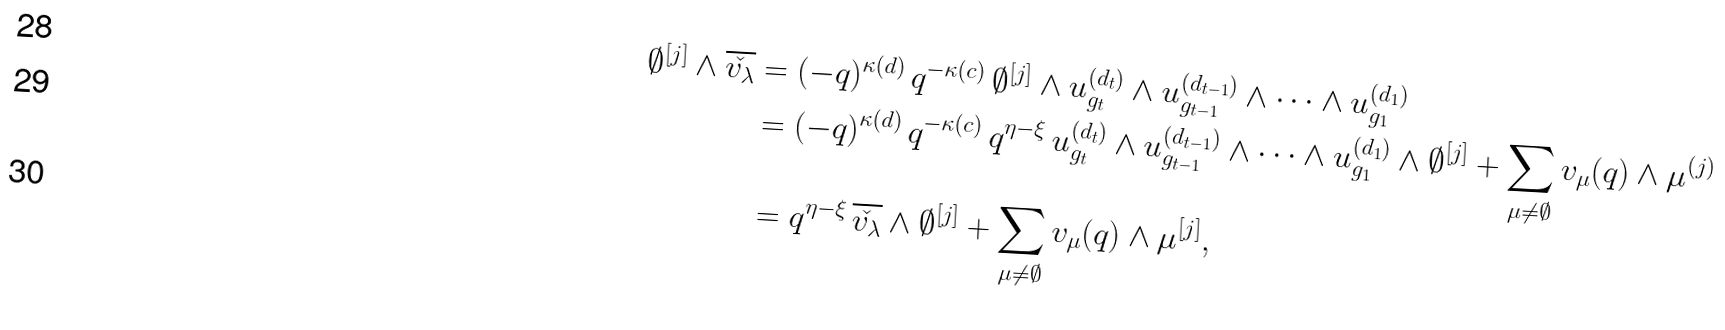Convert formula to latex. <formula><loc_0><loc_0><loc_500><loc_500>\emptyset ^ { [ j ] } \wedge \overline { \check { v _ { \lambda } } } & = ( - q ) ^ { \kappa ( d ) } \, q ^ { - \kappa ( c ) } \, \emptyset ^ { [ j ] } \wedge u _ { g _ { t } } ^ { ( d _ { t } ) } \wedge u _ { g _ { t - 1 } } ^ { ( d _ { t - 1 } ) } \wedge \cdots \wedge u _ { g _ { 1 } } ^ { ( d _ { 1 } ) } \\ & = ( - q ) ^ { \kappa ( d ) } \, q ^ { - \kappa ( c ) } \, q ^ { \eta - \xi } \, u _ { g _ { t } } ^ { ( d _ { t } ) } \wedge u _ { g _ { t - 1 } } ^ { ( d _ { t - 1 } ) } \wedge \cdots \wedge u _ { g _ { 1 } } ^ { ( d _ { 1 } ) } \wedge \emptyset ^ { [ j ] } + \sum _ { \mu \not = \emptyset } v _ { \mu } ( q ) \wedge \mu ^ { ( j ) } \\ & = q ^ { \eta - \xi } \, \overline { \check { v _ { \lambda } } } \wedge \emptyset ^ { [ j ] } + \sum _ { \mu \not = \emptyset } v _ { \mu } ( q ) \wedge \mu ^ { [ j ] } ,</formula> 